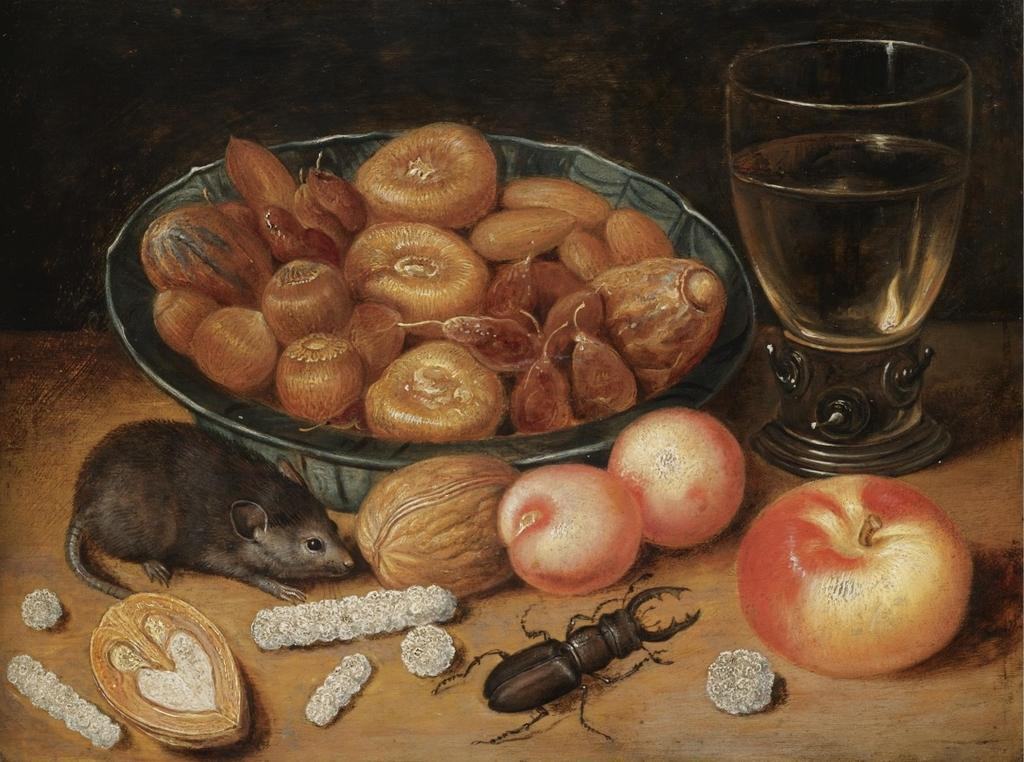What is located in the center of the image? There is a platform in the center of the image. What is on top of the platform? A bowl and a glass are on the platform. Are there any living creatures on the platform? Yes, an insect and a mouse are visible on the platform. What else can be found on the platform? There are food items on the platform. How would you describe the lighting in the image? The background of the image is dark. How many bells can be seen hanging from the platform in the image? There are no bells present on the platform in the image. Are there any brothers interacting with the mouse on the platform? There is no mention of brothers or any interaction with the mouse in the image. 